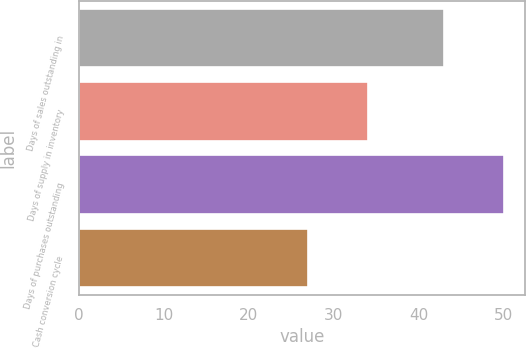Convert chart. <chart><loc_0><loc_0><loc_500><loc_500><bar_chart><fcel>Days of sales outstanding in<fcel>Days of supply in inventory<fcel>Days of purchases outstanding<fcel>Cash conversion cycle<nl><fcel>43<fcel>34<fcel>50<fcel>27<nl></chart> 